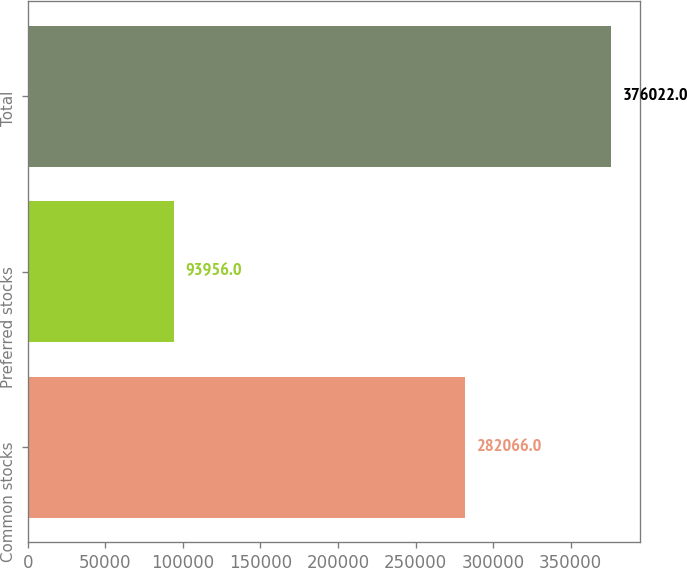Convert chart. <chart><loc_0><loc_0><loc_500><loc_500><bar_chart><fcel>Common stocks<fcel>Preferred stocks<fcel>Total<nl><fcel>282066<fcel>93956<fcel>376022<nl></chart> 